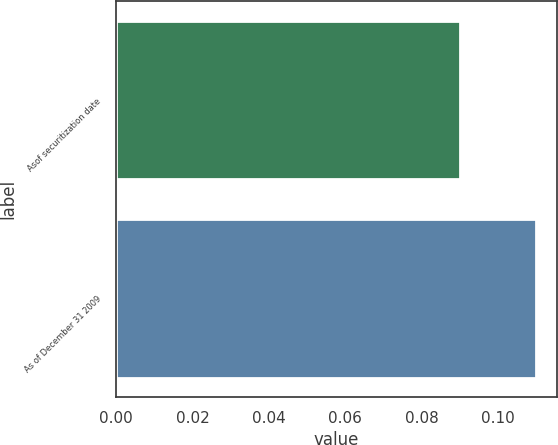Convert chart to OTSL. <chart><loc_0><loc_0><loc_500><loc_500><bar_chart><fcel>Asof securitization date<fcel>As of December 31 2009<nl><fcel>0.09<fcel>0.11<nl></chart> 